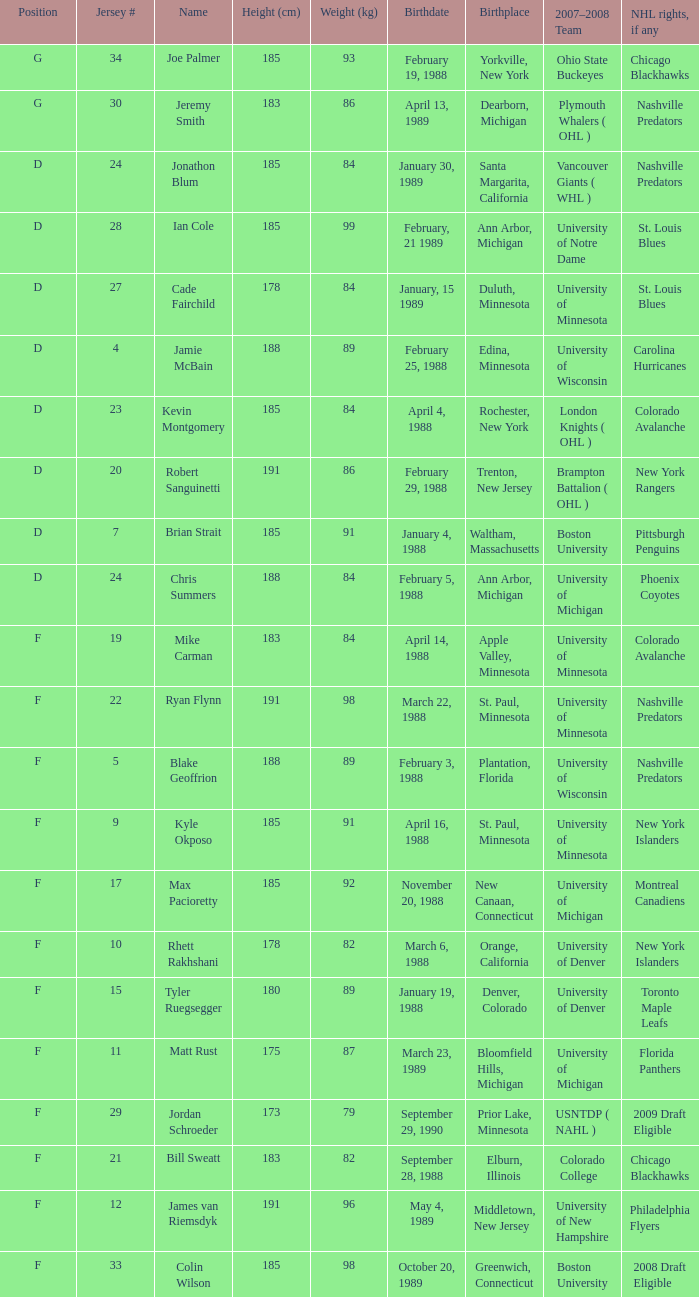Which Height (cm) has a Birthplace of new canaan, connecticut? 1.0. 